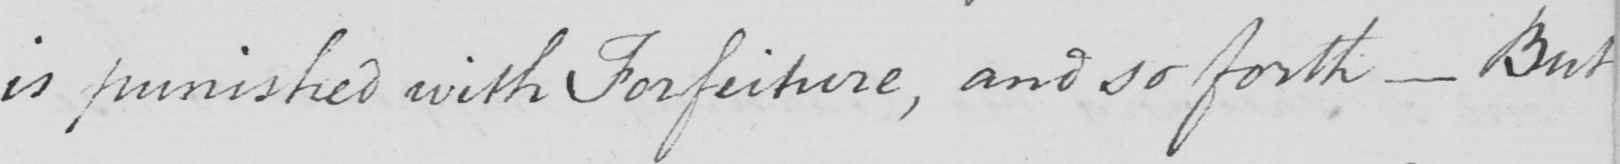Can you tell me what this handwritten text says? is punished with Forfeiture , and so forth  _  But 